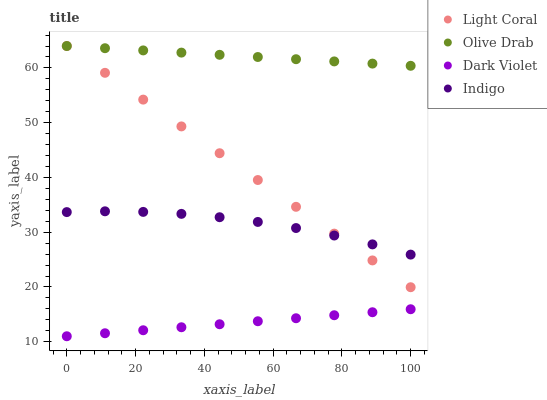Does Dark Violet have the minimum area under the curve?
Answer yes or no. Yes. Does Olive Drab have the maximum area under the curve?
Answer yes or no. Yes. Does Indigo have the minimum area under the curve?
Answer yes or no. No. Does Indigo have the maximum area under the curve?
Answer yes or no. No. Is Olive Drab the smoothest?
Answer yes or no. Yes. Is Indigo the roughest?
Answer yes or no. Yes. Is Dark Violet the smoothest?
Answer yes or no. No. Is Dark Violet the roughest?
Answer yes or no. No. Does Dark Violet have the lowest value?
Answer yes or no. Yes. Does Indigo have the lowest value?
Answer yes or no. No. Does Olive Drab have the highest value?
Answer yes or no. Yes. Does Indigo have the highest value?
Answer yes or no. No. Is Dark Violet less than Indigo?
Answer yes or no. Yes. Is Olive Drab greater than Dark Violet?
Answer yes or no. Yes. Does Light Coral intersect Olive Drab?
Answer yes or no. Yes. Is Light Coral less than Olive Drab?
Answer yes or no. No. Is Light Coral greater than Olive Drab?
Answer yes or no. No. Does Dark Violet intersect Indigo?
Answer yes or no. No. 